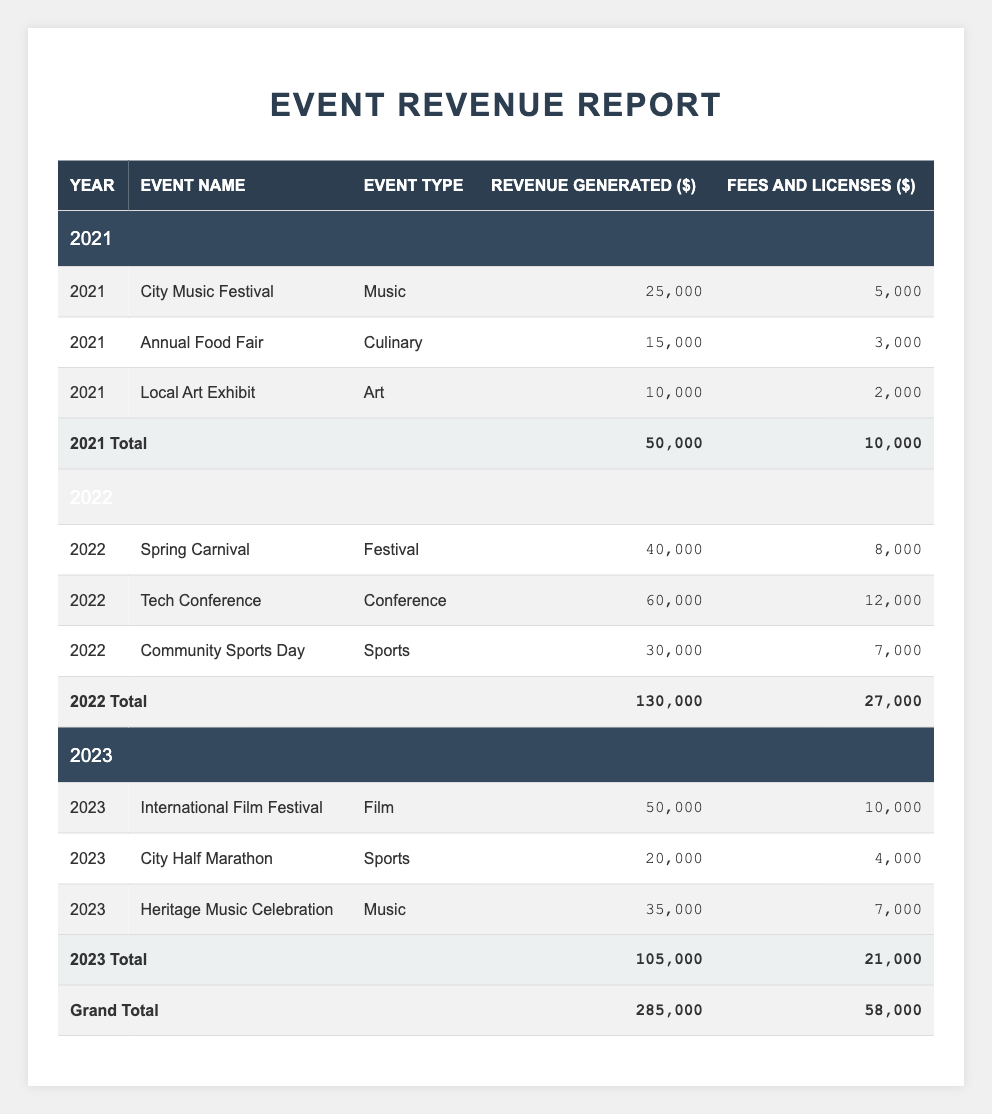What was the total revenue generated from events in 2022? Summing up the revenue generated in 2022 from all events: 40,000 (Spring Carnival) + 60,000 (Tech Conference) + 30,000 (Community Sports Day) equals 130,000.
Answer: 130,000 How much revenue was generated from the City Music Festival? The revenue generated from the City Music Festival in 2021 is directly stated in the table as 25,000.
Answer: 25,000 What were the fees and licenses for the Annual Food Fair? The table lists the fees and licenses for the Annual Food Fair in 2021 as 3,000.
Answer: 3,000 Which year had the highest total revenue generated from events? The total revenues for the respective years are: 50,000 (2021), 130,000 (2022), and 105,000 (2023). The highest total is 130,000 in 2022.
Answer: 2022 What is the average revenue generated from events in 2023? The revenue for events in 2023 is 50,000 (International Film Festival), 20,000 (City Half Marathon), and 35,000 (Heritage Music Celebration). Summing these gives 105,000 and averaging over 3 events gives 105,000 / 3 = 35,000.
Answer: 35,000 Were the fees and licenses greater than 5,000 for the Tech Conference? The table shows fees and licenses for the Tech Conference in 2022 as 12,000, which is greater than 5,000.
Answer: Yes What was the total amount of fees and licenses collected over the three years? You sum the fees and licenses from each year: 10,000 (2021) + 27,000 (2022) + 21,000 (2023) equals a total of 58,000.
Answer: 58,000 How does the total revenue in 2021 compare to the total revenue in 2023? Total revenue in 2021 was 50,000, while in 2023 it was 105,000. The total revenue in 2023 exceeds that of 2021 by 55,000.
Answer: 2023 exceeds 2021 by 55,000 What event generated the highest revenue in 2022? The Tech Conference generated the highest revenue in 2022 at 60,000, as stated in the table.
Answer: Tech Conference What were the total revenue and fees for all events over the three years? The total revenue is 285,000 and the total fees and licenses collected is 58,000, as clearly indicated in the grand total row of the table.
Answer: Revenue: 285,000, Fees: 58,000 